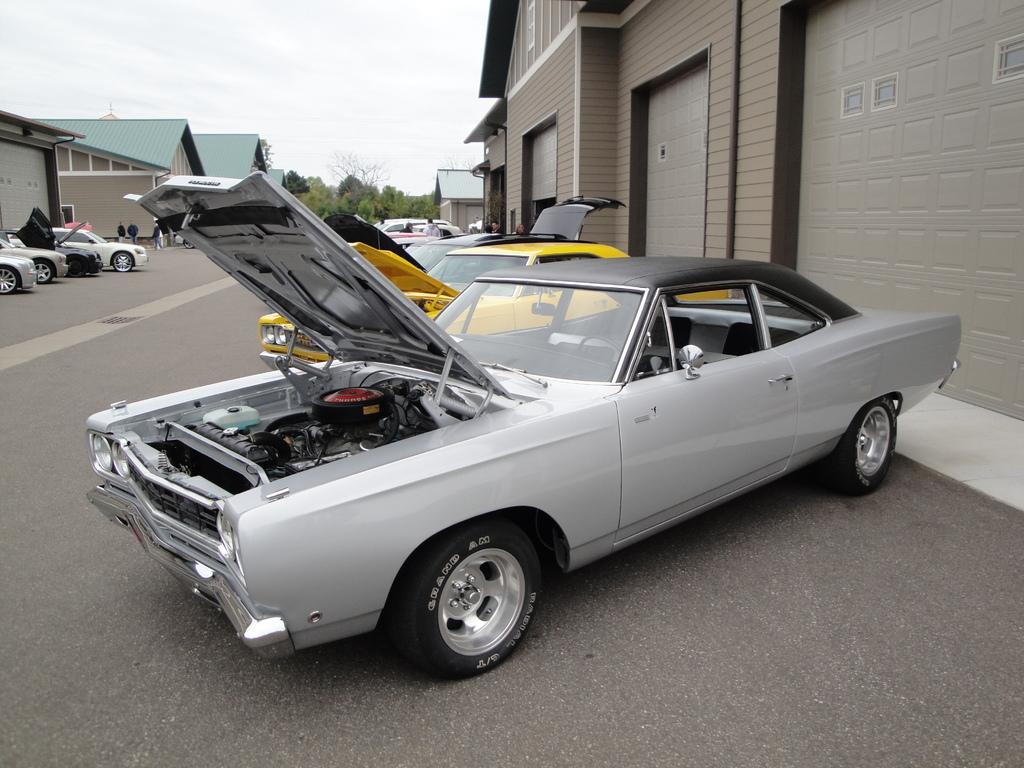In one or two sentences, can you explain what this image depicts? In this image I can see fleets of cars on the road and a crowd. In the background I can see buildings, trees and the sky. This image is taken during a day. 